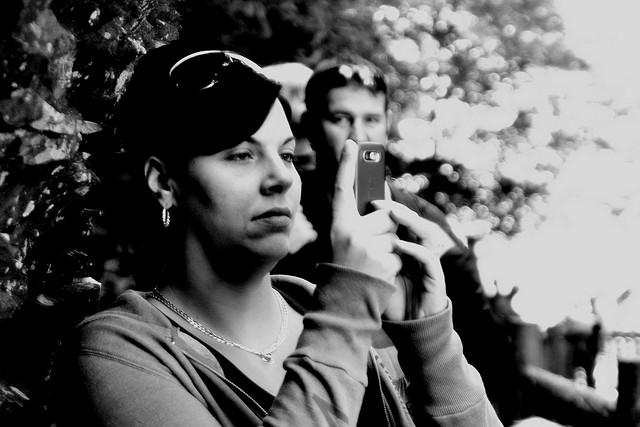What is the man looking at?
Concise answer only. Woman. Is the woman looking at the sky?
Keep it brief. No. Who is wearing glasses?
Concise answer only. No one. What is the woman holding?
Be succinct. Cell phone. What is on the woman's head?
Concise answer only. Sunglasses. 